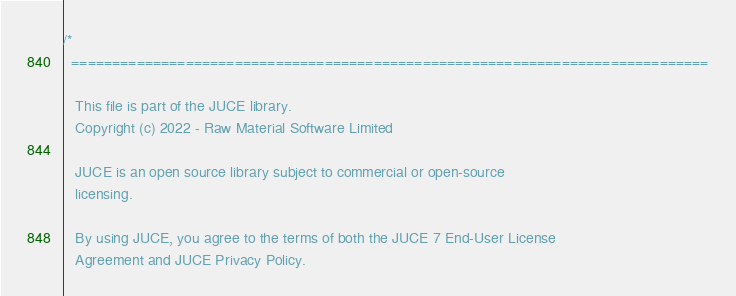<code> <loc_0><loc_0><loc_500><loc_500><_ObjectiveC_>/*
  ==============================================================================

   This file is part of the JUCE library.
   Copyright (c) 2022 - Raw Material Software Limited

   JUCE is an open source library subject to commercial or open-source
   licensing.

   By using JUCE, you agree to the terms of both the JUCE 7 End-User License
   Agreement and JUCE Privacy Policy.
</code> 